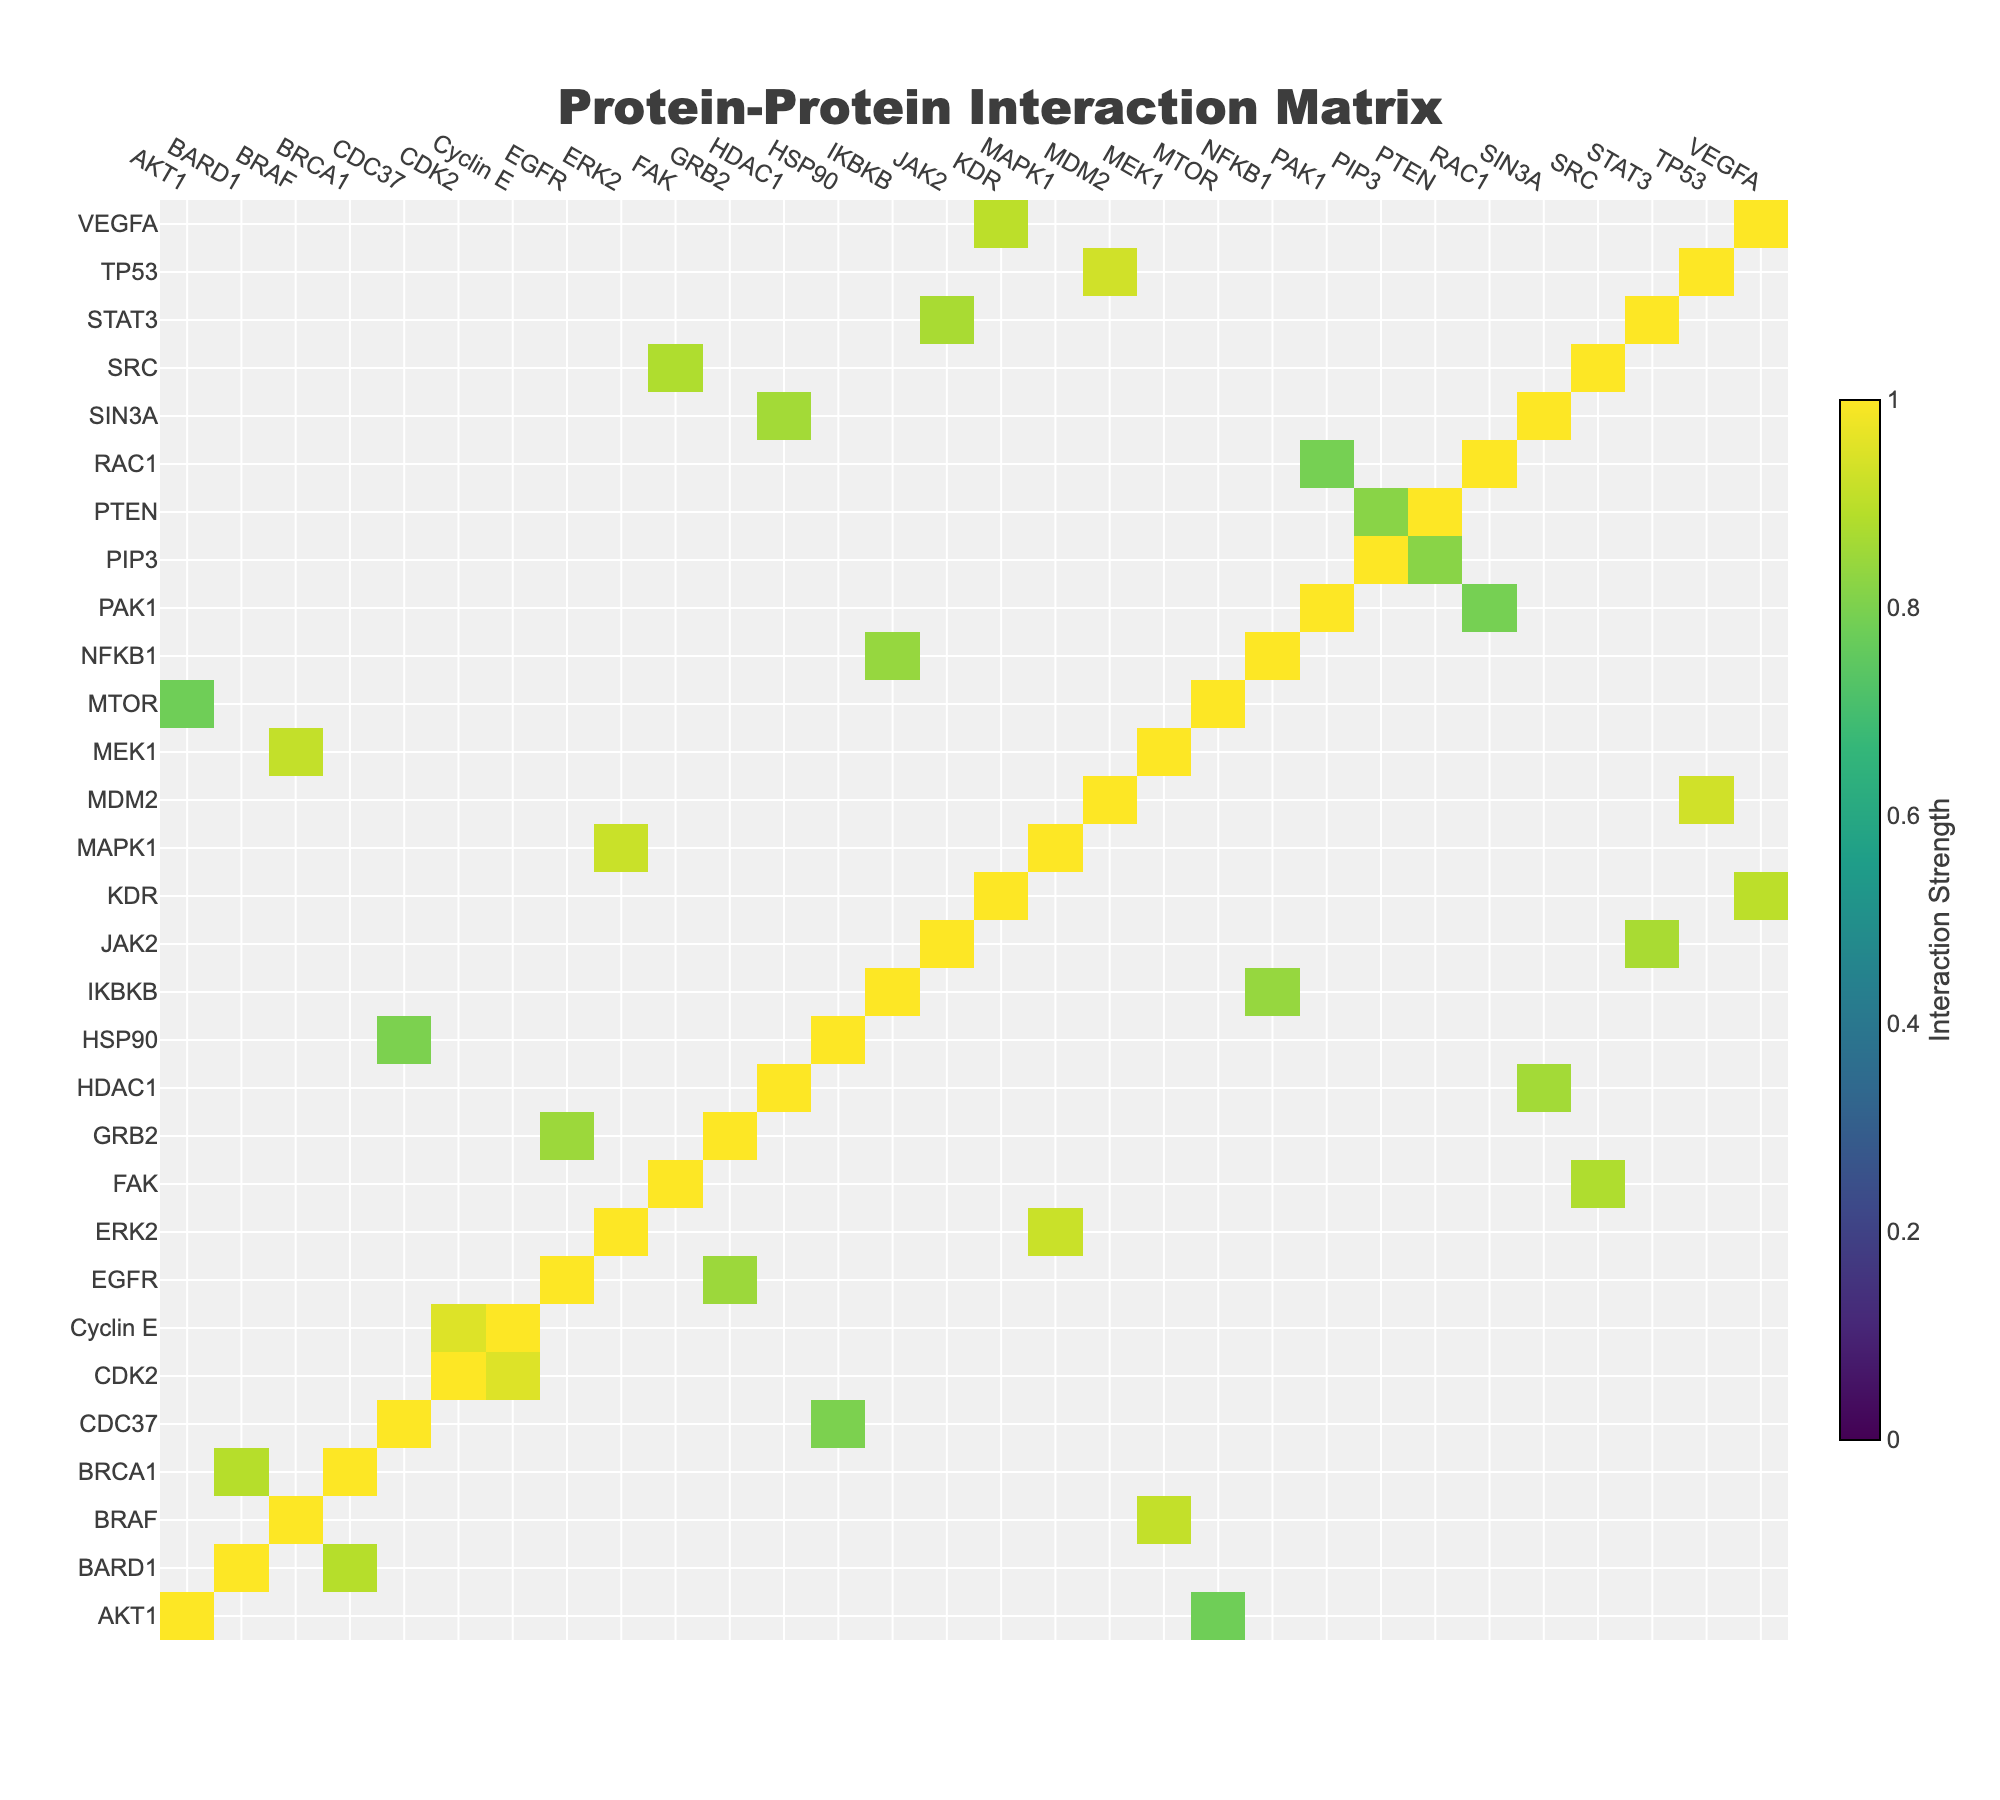What is the interaction strength between EGFR and GRB2? The table shows a direct relationship between EGFR and GRB2 with a specific value listed under the Interaction Strength column. This value is 0.85.
Answer: 0.85 What is the confidence score for the interaction between TP53 and MDM2? By checking the row for TP53 and the corresponding column for MDM2, the table indicates a confidence score of 0.96.
Answer: 0.96 Which protein has the highest interaction strength based on the data presented? By scanning through the Interaction Strength values, CDK2 and Cyclin E present the highest value of 0.95.
Answer: CDK2 and Cyclin E Is the interaction strength between SRC and FAK greater than 0.8? Looking at the table, the interaction strength for SRC and FAK is listed as 0.88, which is indeed greater than 0.8.
Answer: Yes What is the average interaction strength of the interactions listed in the table? The interaction strengths are summed up: 0.85 + 0.93 + 0.78 + 0.91 + 0.82 + 0.89 + 0.95 + 0.87 + 0.80 + 0.92 + 0.84 + 0.88 + 0.79 + 0.86 + 0.90 = 13.30. Dividing by the number of pairs (15), yields an average interaction strength of 0.887.
Answer: 0.887 Which pair has a higher interaction strength: MAPK1 and ERK2 or PTEN and PIP3? The values are checked from the table: MAPK1 and ERK2 have 0.92, while PTEN and PIP3 is 0.82. Since 0.92 is greater than 0.82, MAPK1 and ERK2 has the higher strength.
Answer: MAPK1 and ERK2 How many total unique proteins are involved in the interactions? By identifying unique entries from both Protein1 and Protein2 columns, there are 14 unique proteins in total.
Answer: 14 Is it true that all interactions listed have a confidence score of 0.85 or higher? Upon examining each confidence score in the table, all scores are indeed greater than or equal to 0.85. Therefore, the statement is true.
Answer: Yes What is the relationship between the interaction strength and confidence score for AKT1 and MTOR? The table shows an interaction strength of 0.78 and a confidence score of 0.89 for AKT1 and MTOR. The confidence score is significantly higher than the interaction strength.
Answer: Confidence score is higher Which two proteins have the lowest interaction strength, and what is that value? The lowest value observed in the Interaction Strength column is 0.78 between AKT1 and MTOR.
Answer: AKT1 and MTOR, 0.78 If you were to group interactions based on a threshold of 0.85, how many interactions would qualify? Interactions above 0.85 are: EGFR/GRB2, TP53/MDM2, BRAF/MEK1, CDK2/Cyclin E, BRCA1/BARD1, SRC/FAK, and MAPK1/ERK2, totaling 7 interactions qualifying above the threshold.
Answer: 7 